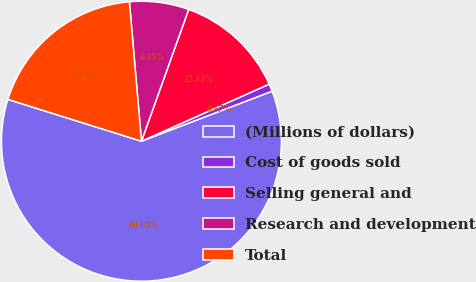<chart> <loc_0><loc_0><loc_500><loc_500><pie_chart><fcel>(Millions of dollars)<fcel>Cost of goods sold<fcel>Selling general and<fcel>Research and development<fcel>Total<nl><fcel>60.65%<fcel>0.87%<fcel>12.83%<fcel>6.85%<fcel>18.8%<nl></chart> 